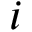<formula> <loc_0><loc_0><loc_500><loc_500>i</formula> 